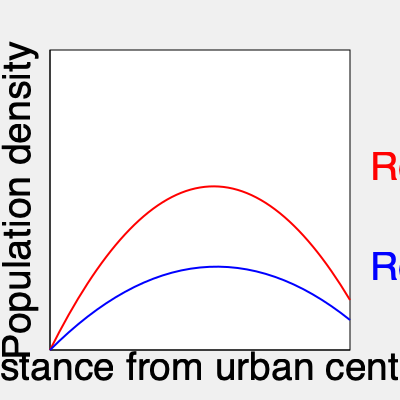The graph shows population density patterns for two rural regions (A and B) as a function of distance from the nearest urban center. Which region is likely to have a more challenging distribution of social services, and why? To determine which region poses a greater challenge for social service distribution, we need to analyze the population density patterns:

1. Region A (red line):
   - Shows a sharp decline in population density as distance from the urban center increases.
   - Has a high population density near the urban center, which rapidly decreases.
   - The curve flattens out at greater distances, indicating very low population density in remote areas.

2. Region B (blue line):
   - Displays a more gradual decline in population density.
   - Has a lower initial population density near the urban center compared to Region A.
   - Maintains a relatively higher population density at greater distances from the urban center.

3. Challenges in social service distribution:
   - Region A:
     a) Concentration of services near the urban center may be efficient for the densely populated areas.
     b) Very low density in remote areas might lead to underserved populations.
   - Region B:
     a) More evenly distributed population requires a wider spread of services.
     b) Maintaining service quality across a larger area with moderate density is challenging.

4. Conclusion:
   Region B is likely to have a more challenging distribution of social services because:
   - It requires a more extensive network of service points to cover the wider spread of population.
   - The relatively higher population density in remote areas demands more resources and personnel.
   - Balancing service quality and accessibility across a larger area is more complex.

In contrast, Region A allows for more concentrated services near the urban center, with potentially mobile or specialized services for the sparsely populated remote areas.
Answer: Region B 